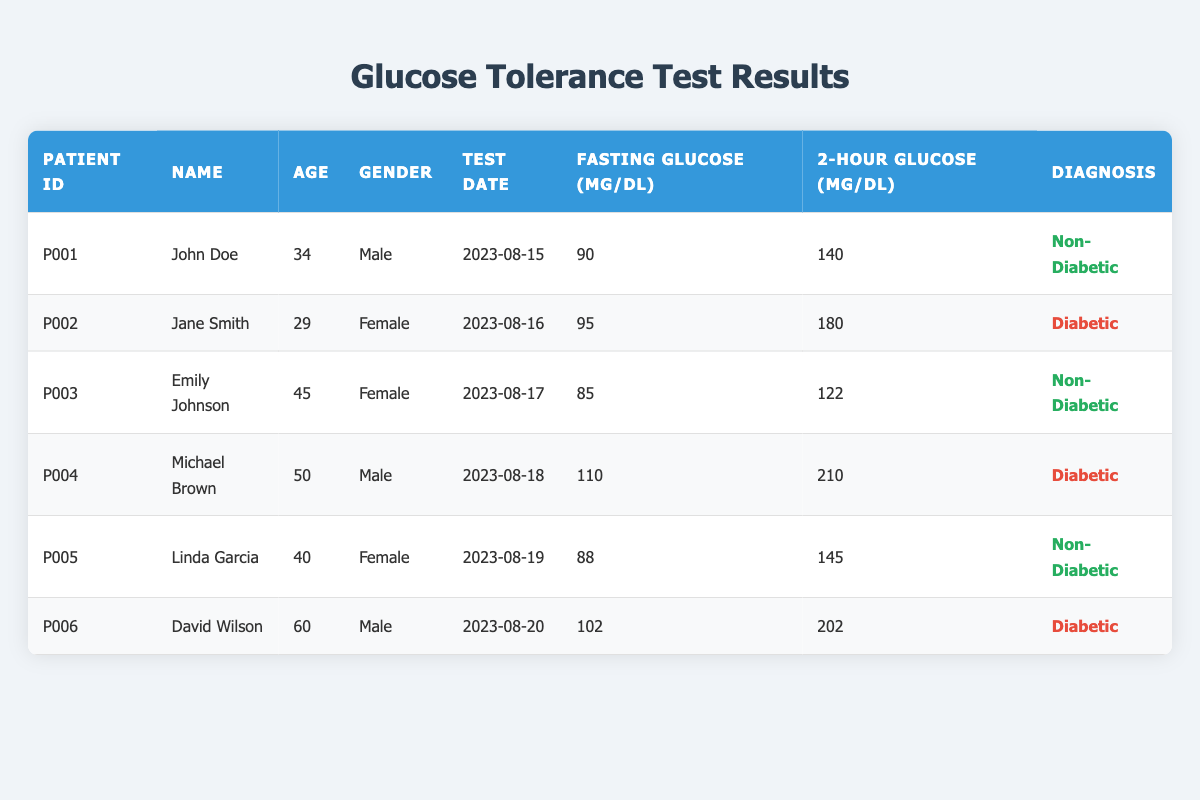What is the diagnosis of patient P002? The diagnosis for patient P002, Jane Smith, is listed in the diagnosis column of the table. Looking at the row corresponding to patient P002, it states "Diabetic."
Answer: Diabetic How many diabetic patients are there in the table? By reviewing the diagnosis column, we find the entries for diabetic patients. The patients with "Diabetic" listed are Jane Smith (P002), Michael Brown (P004), and David Wilson (P006). There are three entries with the diagnosis "Diabetic."
Answer: 3 What is the highest fasting glucose level recorded in the table? The fasting glucose levels are recorded in the fasting glucose column. Scanning through the column, Michael Brown (P004) has the highest fasting glucose level of 110 mg/dL.
Answer: 110 What is the average age of non-diabetic patients? The ages of non-diabetic patients listed are John Doe (34), Emily Johnson (45), and Linda Garcia (40). To find the average, we sum these ages: 34 + 45 + 40 = 119. There are three non-diabetic patients, so the average age is 119 / 3 = 39.67.
Answer: 39.67 Is there a patient aged over 50 who is non-diabetic? To answer this, check the ages and diagnoses of all patients. David Wilson, aged 60, is listed as diabetic. The other patients aged over 50 are also diabetic (Michael Brown, 50). Hence, there are no non-diabetic patients over age 50.
Answer: No What is the difference between the highest and lowest 2-hour glucose levels? The highest 2-hour glucose level belongs to Michael Brown (P004) at 210 mg/dL, and the lowest is Emily Johnson (P003) at 122 mg/dL. The difference is calculated as 210 - 122 = 88 mg/dL.
Answer: 88 Which patient has the lowest fasting glucose level? Looking through the fasting glucose levels, the lowest recorded level is 85 mg/dL for Emily Johnson (P003).
Answer: Emily Johnson How many male patients had a fasting glucose level above 100 mg/dL? The male patients listed are John Doe (90 mg/dL), Michael Brown (110 mg/dL), and David Wilson (102 mg/dL). Out of these, Michael Brown and David Wilson have fasting glucose levels above 100 mg/dL. Therefore, there are two male patients with fasting glucose levels above 100 mg/dL.
Answer: 2 What is the 2-hour glucose level of the youngest patient in the table? The youngest patient is Jane Smith (P002), aged 29, with a 2-hour glucose level of 180 mg/dL.
Answer: 180 